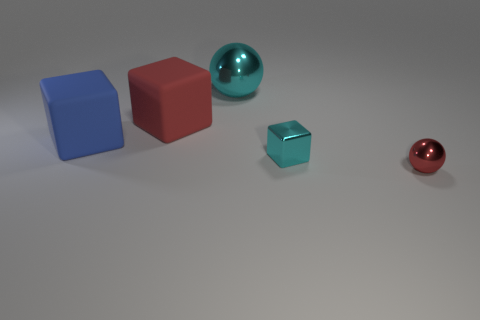What number of big red rubber objects are there?
Your answer should be compact. 1. How many objects are big gray shiny cylinders or large blocks that are behind the blue matte object?
Provide a short and direct response. 1. Is there anything else that has the same shape as the small red metal thing?
Ensure brevity in your answer.  Yes. Is the size of the matte block left of the red rubber thing the same as the big cyan metal ball?
Your answer should be compact. Yes. What number of matte objects are either big blue things or large red objects?
Provide a succinct answer. 2. There is a metal ball that is in front of the big cyan ball; how big is it?
Give a very brief answer. Small. Does the big metallic thing have the same shape as the big red matte thing?
Provide a short and direct response. No. What number of tiny objects are either red cubes or green blocks?
Your answer should be compact. 0. There is a large cyan metallic thing; are there any large cyan spheres on the left side of it?
Your response must be concise. No. Is the number of red blocks in front of the metallic cube the same as the number of tiny cyan metallic cubes?
Keep it short and to the point. No. 